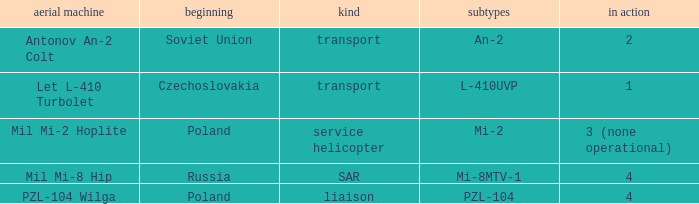Tell me the origin for mi-2 Poland. 